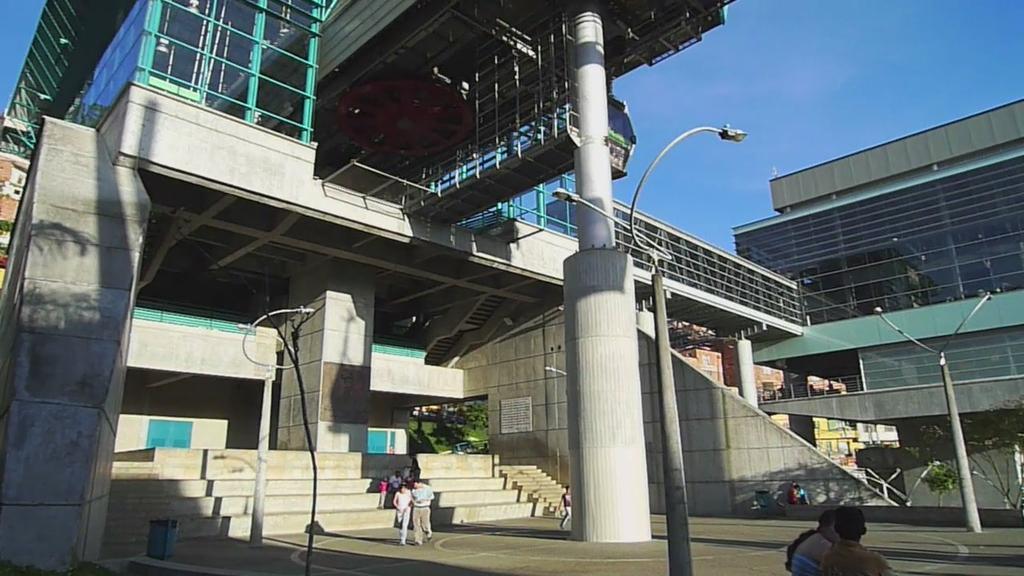Could you give a brief overview of what you see in this image? In this picture there are buildings and trees and there are street lights. In the foreground there are group of people. At the bottom right there are two people. At the top there is sky. At the bottom there is a road. 